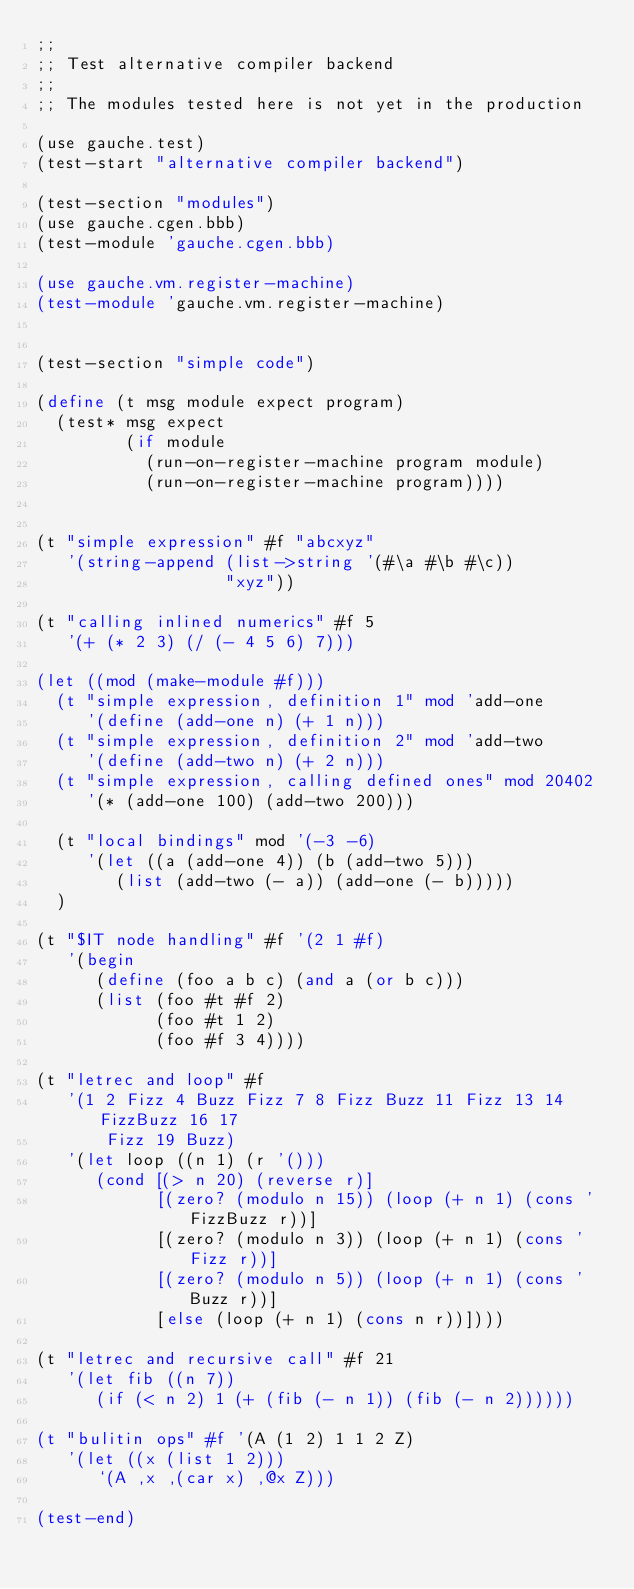<code> <loc_0><loc_0><loc_500><loc_500><_Scheme_>;;
;; Test alternative compiler backend
;;
;; The modules tested here is not yet in the production

(use gauche.test)
(test-start "alternative compiler backend")

(test-section "modules")
(use gauche.cgen.bbb)
(test-module 'gauche.cgen.bbb)

(use gauche.vm.register-machine)
(test-module 'gauche.vm.register-machine)


(test-section "simple code")

(define (t msg module expect program)
  (test* msg expect
         (if module
           (run-on-register-machine program module)
           (run-on-register-machine program))))


(t "simple expression" #f "abcxyz"
   '(string-append (list->string '(#\a #\b #\c))
                   "xyz"))

(t "calling inlined numerics" #f 5
   '(+ (* 2 3) (/ (- 4 5 6) 7)))

(let ((mod (make-module #f)))
  (t "simple expression, definition 1" mod 'add-one
     '(define (add-one n) (+ 1 n)))
  (t "simple expression, definition 2" mod 'add-two
     '(define (add-two n) (+ 2 n)))
  (t "simple expression, calling defined ones" mod 20402
     '(* (add-one 100) (add-two 200)))

  (t "local bindings" mod '(-3 -6)
     '(let ((a (add-one 4)) (b (add-two 5)))
        (list (add-two (- a)) (add-one (- b)))))
  )

(t "$IT node handling" #f '(2 1 #f)
   '(begin
      (define (foo a b c) (and a (or b c)))
      (list (foo #t #f 2)
            (foo #t 1 2)
            (foo #f 3 4))))

(t "letrec and loop" #f
   '(1 2 Fizz 4 Buzz Fizz 7 8 Fizz Buzz 11 Fizz 13 14 FizzBuzz 16 17
       Fizz 19 Buzz)
   '(let loop ((n 1) (r '()))
      (cond [(> n 20) (reverse r)]
            [(zero? (modulo n 15)) (loop (+ n 1) (cons 'FizzBuzz r))]
            [(zero? (modulo n 3)) (loop (+ n 1) (cons 'Fizz r))]
            [(zero? (modulo n 5)) (loop (+ n 1) (cons 'Buzz r))]
            [else (loop (+ n 1) (cons n r))])))

(t "letrec and recursive call" #f 21
   '(let fib ((n 7))
      (if (< n 2) 1 (+ (fib (- n 1)) (fib (- n 2))))))

(t "bulitin ops" #f '(A (1 2) 1 1 2 Z)
   '(let ((x (list 1 2)))
      `(A ,x ,(car x) ,@x Z)))

(test-end)
</code> 